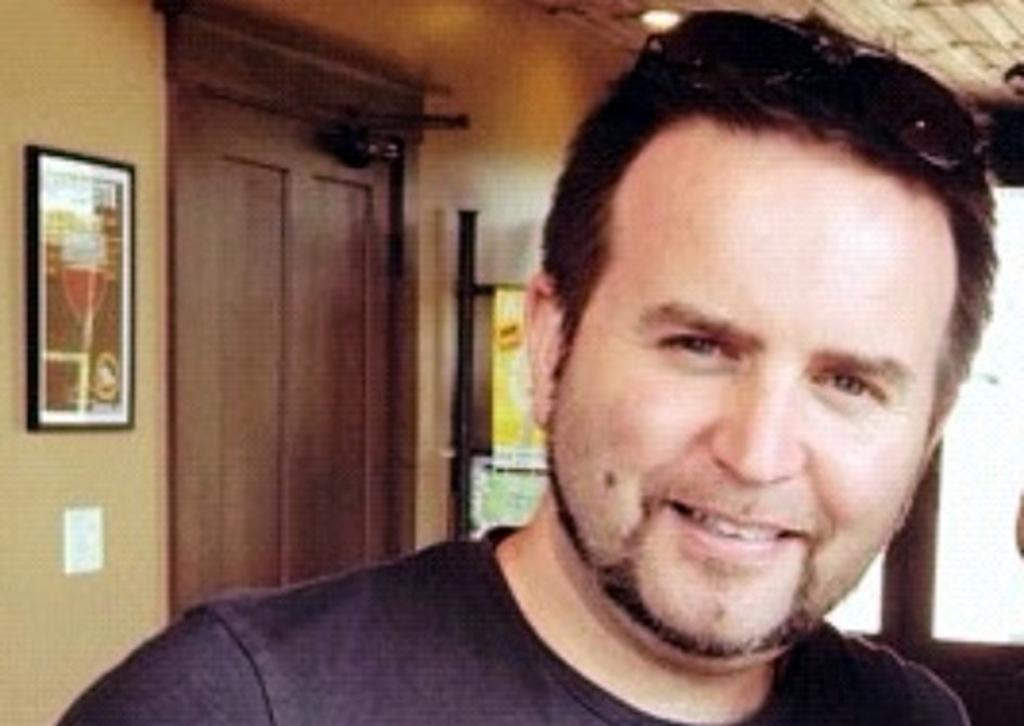Who is present in the image? There is a man in the image. What is the man's facial expression? The man is smiling. What can be seen on the wall in the background? There is a frame on the wall in the background. What architectural feature is visible in the background? There is a door in the background. What type of milk is the man holding in the image? There is no milk present in the image; the man is not holding anything. 